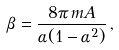Convert formula to latex. <formula><loc_0><loc_0><loc_500><loc_500>\beta = \frac { 8 \pi \, m A } { \alpha ( 1 - \alpha ^ { 2 } ) } \, ,</formula> 